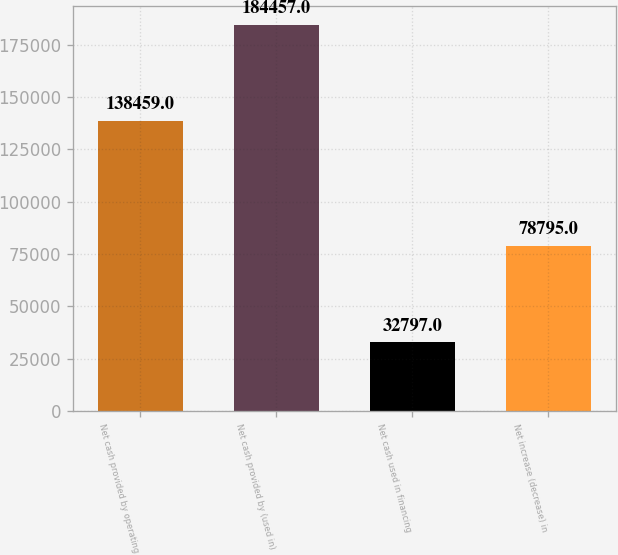Convert chart. <chart><loc_0><loc_0><loc_500><loc_500><bar_chart><fcel>Net cash provided by operating<fcel>Net cash provided by (used in)<fcel>Net cash used in financing<fcel>Net increase (decrease) in<nl><fcel>138459<fcel>184457<fcel>32797<fcel>78795<nl></chart> 